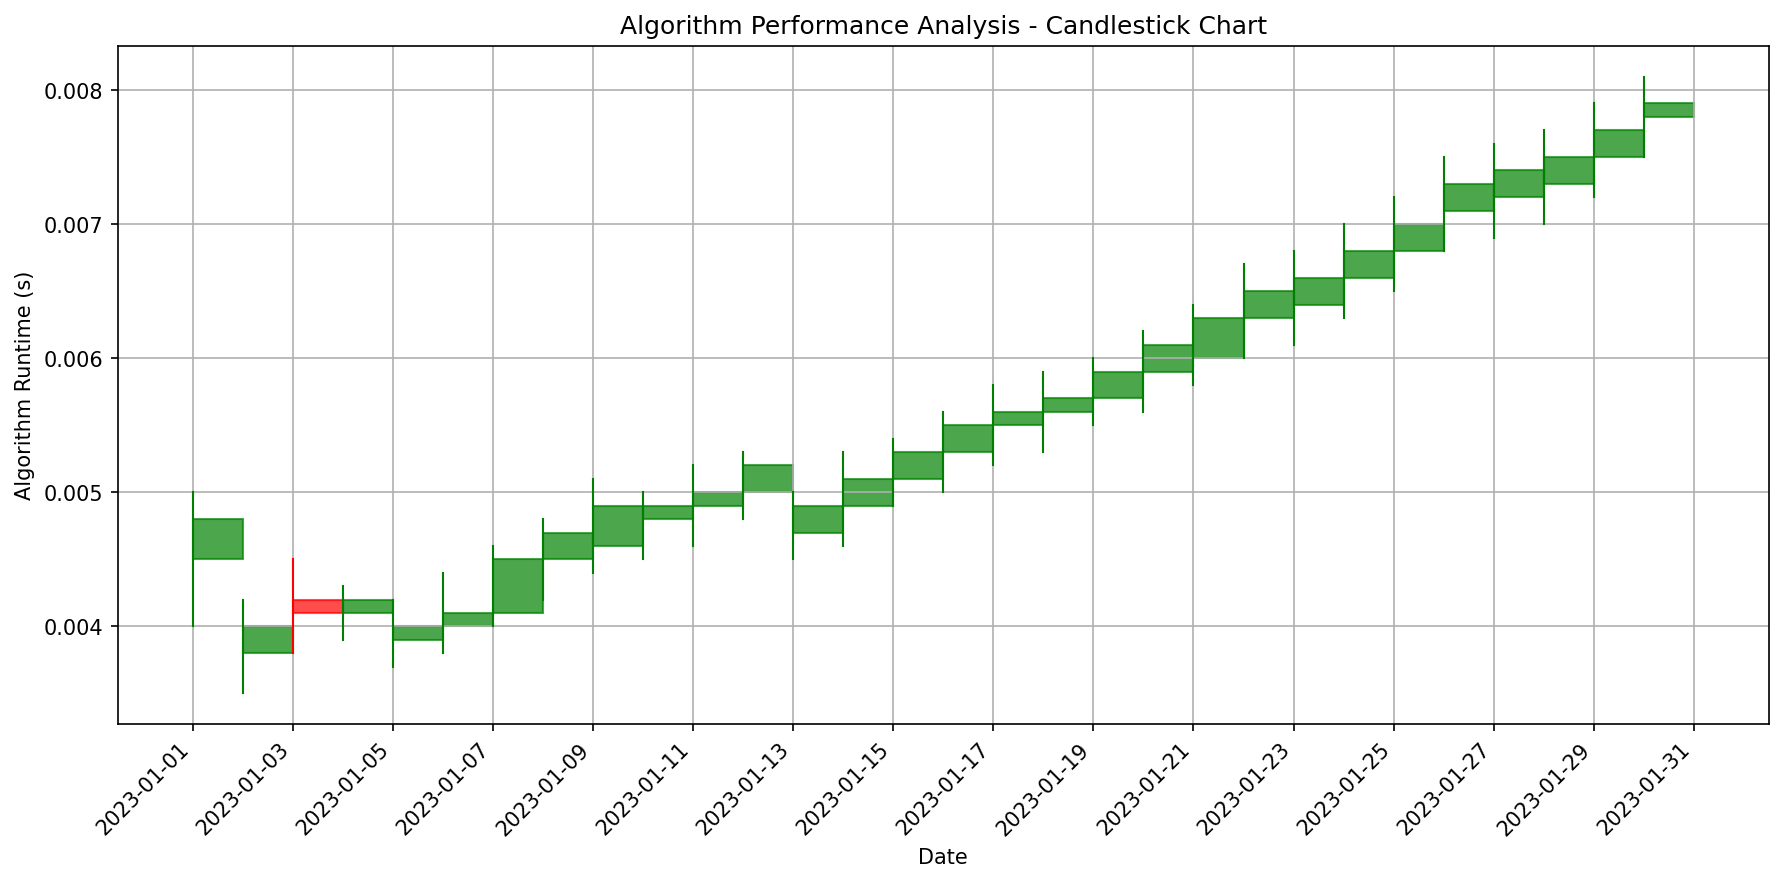What is the general trend of the closing values from January 1 to January 30? By observing the height of the rectangles for the closing values over time, we can see that the closing values tend to increase over the duration. Initially, they start around 0.0048 on January 1 and end around 0.0079 on January 30.
Answer: Increasing Which date had the highest runtime? Refer to the highest value in the 'High' column on the chart. The highest runtime reached is around 0.0081, which is on January 30.
Answer: January 30 How many times did the closing value decrease compared to the previous day's closing value? To determine the count, look for red rectangles, as they represent days when the closing value was lower than the opening value. Count all red rectangles in the chart.
Answer: 5 times What is the average closing value between January 10 and January 20? Collect the 'Close' values from January 10 to January 20, sum them up, and then divide by the number of days in this period. The values are 0.0049, 0.0050, 0.0052, 0.0049, 0.0051, 0.0053, 0.0055, 0.0056, 0.0057, 0.0059, 0.0061. Summing these values gives 0.0562 and dividing by 11 days gives approximately 0.0051.
Answer: 0.0051 On which dates did the closing value exactly match the opening value? Look for rectangles where the height is zero, indicating that the closing value is the same as the opening value.
Answer: None Compare the runtime ranges (difference between High and Low values) for January 15 and January 20. Which one is greater? Calculate the difference between the 'High' and 'Low' values for both dates. On January 15, the difference is 0.0054 - 0.0049 = 0.0005. On January 20, the difference is 0.0062 - 0.0056 = 0.0006. The difference on January 20 is greater.
Answer: January 20 Which date experienced the largest increase in closing value compared to the previous day? Calculate the difference between the 'Close' values for consecutive days. Identify the date with the highest positive difference. The largest increase is from January 21 (0.0063) to January 22 (0.0065) with a difference of 0.0002.
Answer: January 22 Which date had the smallest range of runtime, and what was the value of this range? Calculate the range (High - Low) for each date and find the smallest range value. The smallest range is on January 12 with a range of 0.0053 - 0.0048 = 0.0005.
Answer: January 12, 0.0005 